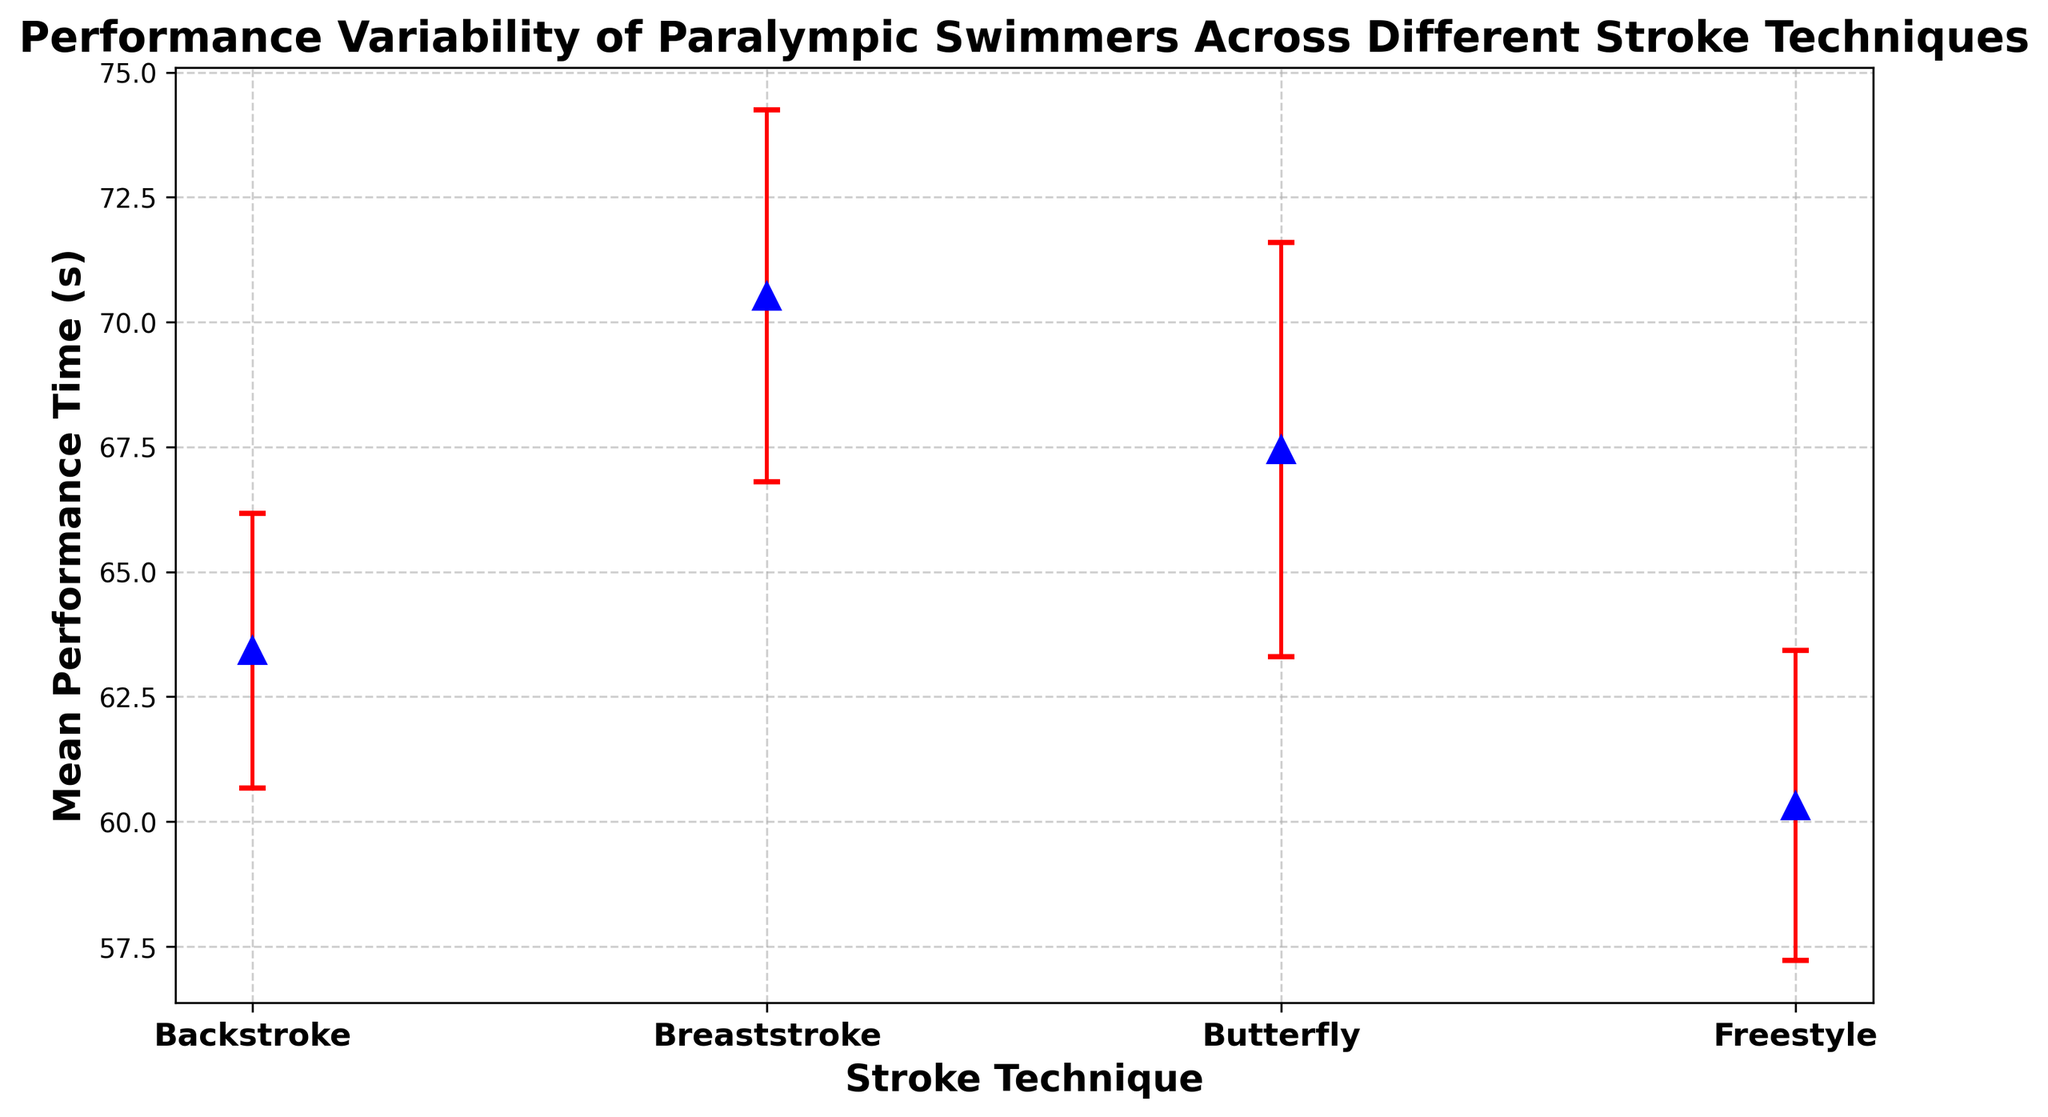What is the average mean performance time across all stroke techniques? To find the average mean performance time, sum the mean performance times of all four stroke techniques and divide by the number of techniques. Thus, the average is (60.325 + 63.425 + 70.525 + 67.2) / 4 = 65.369
Answer: 65.369 Which stroke technique has the smallest mean performance time? By looking at the error bars and means plotted, Freestyle consistently has the lowest mean performance time.
Answer: Freestyle Between Backstroke and Butterfly, which has a larger overall error range (standard deviation)? From the error bars, Butterfly always has a larger standard deviation compared to Backstroke, with Butterfly averaging around 4.15 and Backstroke around 2.75.
Answer: Butterfly What is the difference in mean performance time between the fastest and slowest stroke techniques? The fastest stroke is Freestyle (60.325 seconds) and the slowest is Breaststroke (70.525 seconds). The difference is 70.525 - 60.325 = 10.20 seconds.
Answer: 10.20 seconds If a swimmer improves their Butterfly time to match their Freestyle time, what is the percentage decrease? Using the mean values, the Butterfly mean time is 67.2 seconds, and the Freestyle mean time is 60.325 seconds. The percentage decrease is ((67.2 - 60.325) / 67.2) * 100 ≈ 10.24%
Answer: 10.24% Which stroke technique has the most variability in performance times? The technique with the largest average standard deviation (visualized by the length of the error bars) is Butterfly, with an average standard deviation of 4.15 seconds.
Answer: Butterfly How does the average mean performance time for Backstroke compare to that for Freestyle? The average mean performance time for Backstroke is 63.425 seconds, whereas for Freestyle it is 60.325 seconds. Therefore, Backstroke is slower than Freestyle by 3.1 seconds.
Answer: Backstroke is slower by 3.1 seconds Considering the variabilities, which technique is more consistent: Breaststroke or Butterfly? Consistency is indicated by smaller error bars (standard deviations). Breaststroke has a smaller average standard deviation (3.725 seconds) compared to Butterfly (4.15 seconds), making it more consistent.
Answer: Breaststroke 